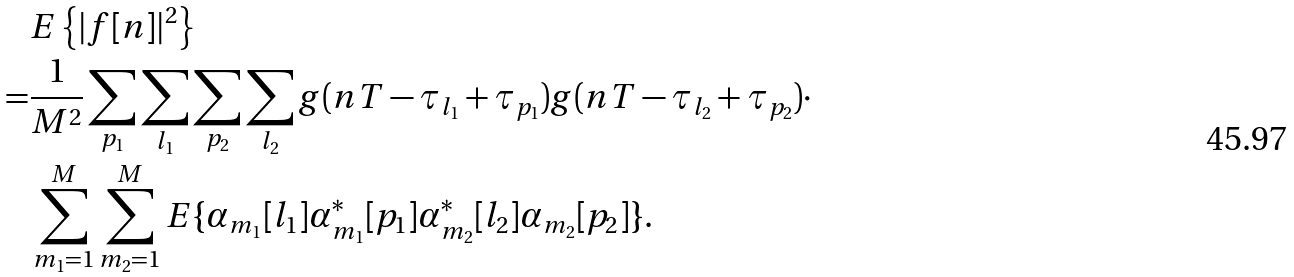Convert formula to latex. <formula><loc_0><loc_0><loc_500><loc_500>& E \left \{ | f [ n ] | ^ { 2 } \right \} \\ = & \frac { 1 } { M ^ { 2 } } \sum _ { p _ { 1 } } \sum _ { l _ { 1 } } \sum _ { p _ { 2 } } \sum _ { l _ { 2 } } g ( n T - \tau _ { l _ { 1 } } + \tau _ { p _ { 1 } } ) g ( n T - \tau _ { l _ { 2 } } + \tau _ { p _ { 2 } } ) \cdot \\ & \sum _ { m _ { 1 } = 1 } ^ { M } \sum _ { m _ { 2 } = 1 } ^ { M } E \{ \alpha _ { m _ { 1 } } [ l _ { 1 } ] \alpha _ { m _ { 1 } } ^ { * } [ p _ { 1 } ] \alpha _ { m _ { 2 } } ^ { * } [ l _ { 2 } ] \alpha _ { m _ { 2 } } [ p _ { 2 } ] \} .</formula> 